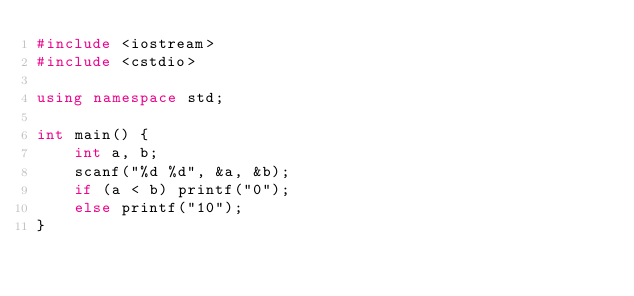Convert code to text. <code><loc_0><loc_0><loc_500><loc_500><_C++_>#include <iostream>
#include <cstdio>

using namespace std;

int main() {
	int a, b;
	scanf("%d %d", &a, &b);
	if (a < b) printf("0");
	else printf("10");
}</code> 